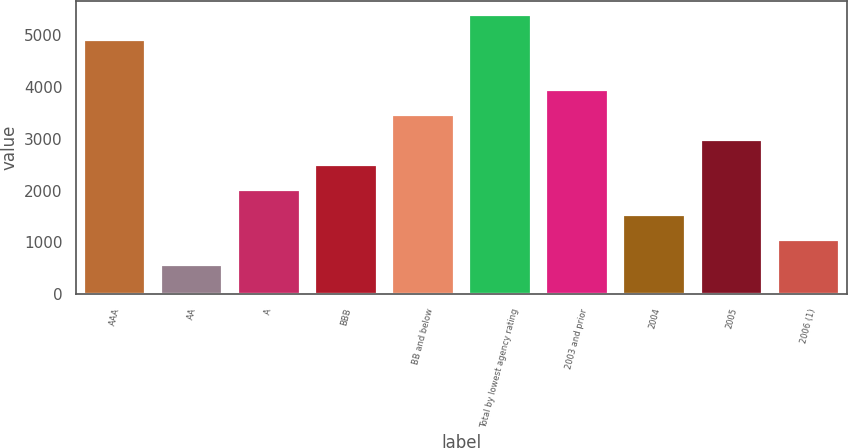<chart> <loc_0><loc_0><loc_500><loc_500><bar_chart><fcel>AAA<fcel>AA<fcel>A<fcel>BBB<fcel>BB and below<fcel>Total by lowest agency rating<fcel>2003 and prior<fcel>2004<fcel>2005<fcel>2006 (1)<nl><fcel>4901.2<fcel>571.84<fcel>2014.96<fcel>2496<fcel>3458.08<fcel>5382.24<fcel>3939.12<fcel>1533.92<fcel>2977.04<fcel>1052.88<nl></chart> 